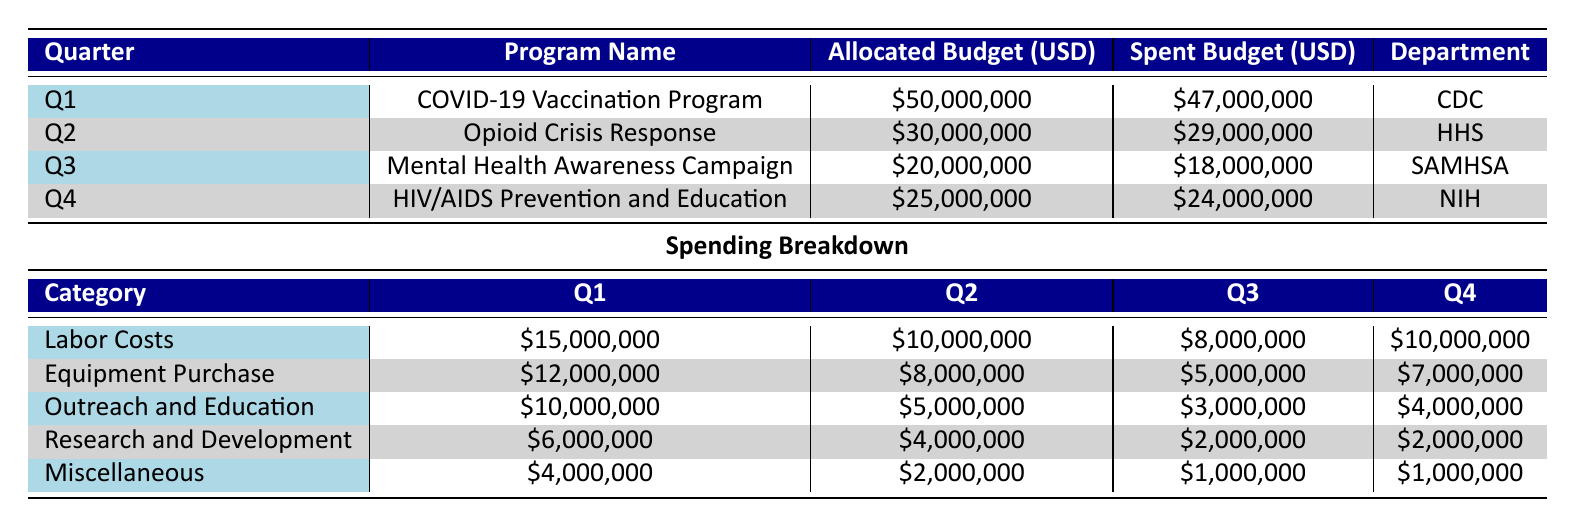What is the total allocated budget for all programs in Q3? The allocated budget for Q3 is given as $20,000,000. Since there is only one program listed in Q3, the total allocated budget for that quarter is simply $20,000,000
Answer: 20,000,000 Which department managed the COVID-19 Vaccination Program? The department listed for the COVID-19 Vaccination Program is CDC, as shown in Q1 of the table
Answer: CDC Is the amount spent on Outreach and Education in Q4 greater than in Q3? In Q4, the amount spent on Outreach and Education is $4,000,000, while in Q3 it is $3,000,000. Comparing these two values shows that $4,000,000 is greater than $3,000,000
Answer: Yes What was the total amount spent on Labor Costs throughout all four quarters? Adding the Labor Costs for all quarters gives: $15,000,000 (Q1) + $10,000,000 (Q2) + $8,000,000 (Q3) + $10,000,000 (Q4) = $43,000,000. Thus, the total Labor Costs amount to $43,000,000
Answer: 43,000,000 Did any program exceed its allocated budget during the year? Reviewing the spent budgets against the allocated budgets shows: Q1 ($47,000,000 spent vs $50,000,000 allocated), Q2 ($29,000,000 spent vs $30,000,000 allocated), Q3 ($18,000,000 spent vs $20,000,000 allocated), and Q4 ($24,000,000 spent vs $25,000,000 allocated) – none exceeded their allocated budgets
Answer: No What is the average spent budget across all quarters? To find the average, sum the spent budgets: $47,000,000 (Q1) + $29,000,000 (Q2) + $18,000,000 (Q3) + $24,000,000 (Q4) = $118,000,000. There are 4 quarters, so the average is $118,000,000 / 4 = $29,500,000
Answer: 29,500,000 Which program had the smallest budget allocation? From the table, the smallest allocated budget is for the Mental Health Awareness Campaign in Q3, which has an allocated budget of $20,000,000 compared to others. Thus, it is the program with the smallest allocation
Answer: Mental Health Awareness Campaign How much was spent on equipment purchases in Q2? The spent amount on Equipment Purchase specifically mentioned in Q2 is $8,000,000 as indicated in the breakdown for that quarter
Answer: 8,000,000 What was the total spending across all categories for Q1? Adding up all spending categories in Q1: Labor Costs ($15,000,000) + Equipment ($12,000,000) + Outreach and Education ($10,000,000) + Research and Development ($6,000,000) + Miscellaneous ($4,000,000) gives a total of $47,000,000
Answer: 47,000,000 